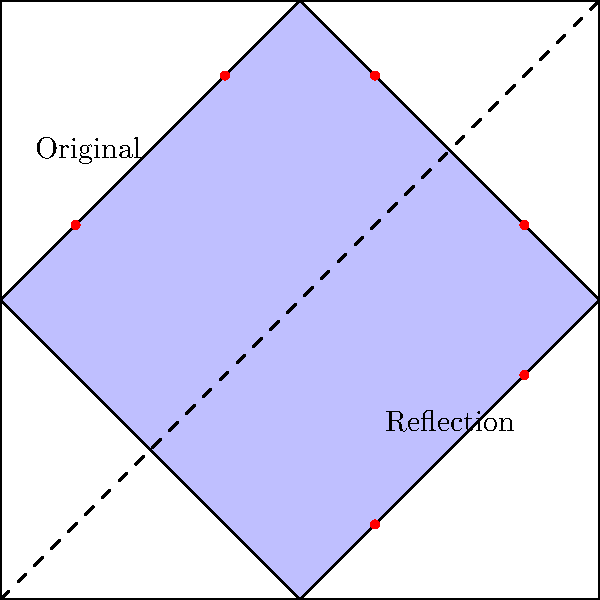In the given diagram, a traditional Azerbaijani carpet pattern is represented by the blue diamond shape and red dots. If this pattern is reflected across the diagonal line, which of the following statements is true about the transformed pattern?

A) The blue diamond will overlap with its original position
B) The red dots will form a square shape
C) The reflected pattern will be entirely outside the original square
D) The reflected blue diamond will touch all four sides of the square Let's analyze this step-by-step:

1) The diagonal line acts as the line of reflection, running from $(0,0)$ to $(4,4)$.

2) When reflecting across this line, points will swap their $x$ and $y$ coordinates. For example, a point at $(1,3)$ would be reflected to $(3,1)$.

3) The blue diamond currently touches the left and top sides of the square. After reflection, it will touch the bottom and right sides.

4) The red dots are currently in the top-left portion of the square. After reflection, they will be in the bottom-right portion.

5) The reflected blue diamond will not overlap with its original position, as it will be entirely in the bottom-right half of the square.

6) The red dots will maintain their relative positions to each other, so they won't form a square shape.

7) The reflected pattern will still be entirely within the original square, just in a different position.

8) After reflection, the blue diamond will indeed touch all four sides of the square:
   - It already touches the top and left sides.
   - Its reflection will touch the bottom and right sides.
   - At the points where it intersects the diagonal, it will touch itself.

Therefore, statement D is correct: The reflected blue diamond will touch all four sides of the square.
Answer: D 